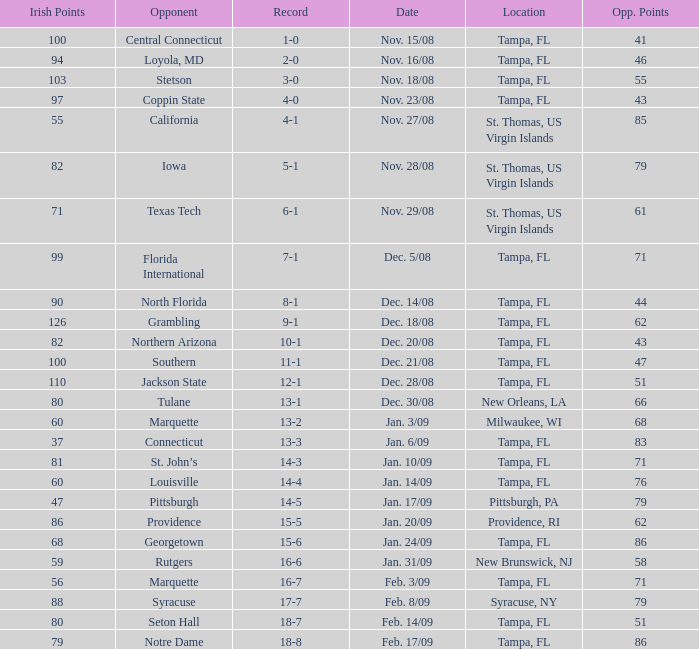What is the number of opponents where the location is syracuse, ny? 1.0. 